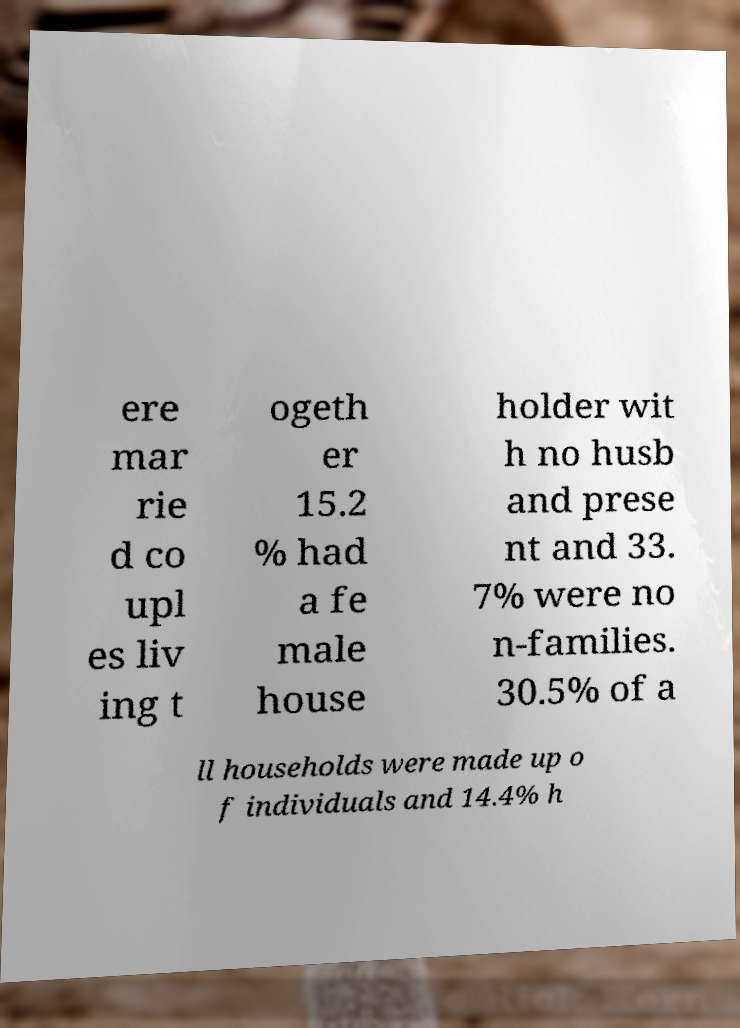Can you read and provide the text displayed in the image?This photo seems to have some interesting text. Can you extract and type it out for me? ere mar rie d co upl es liv ing t ogeth er 15.2 % had a fe male house holder wit h no husb and prese nt and 33. 7% were no n-families. 30.5% of a ll households were made up o f individuals and 14.4% h 